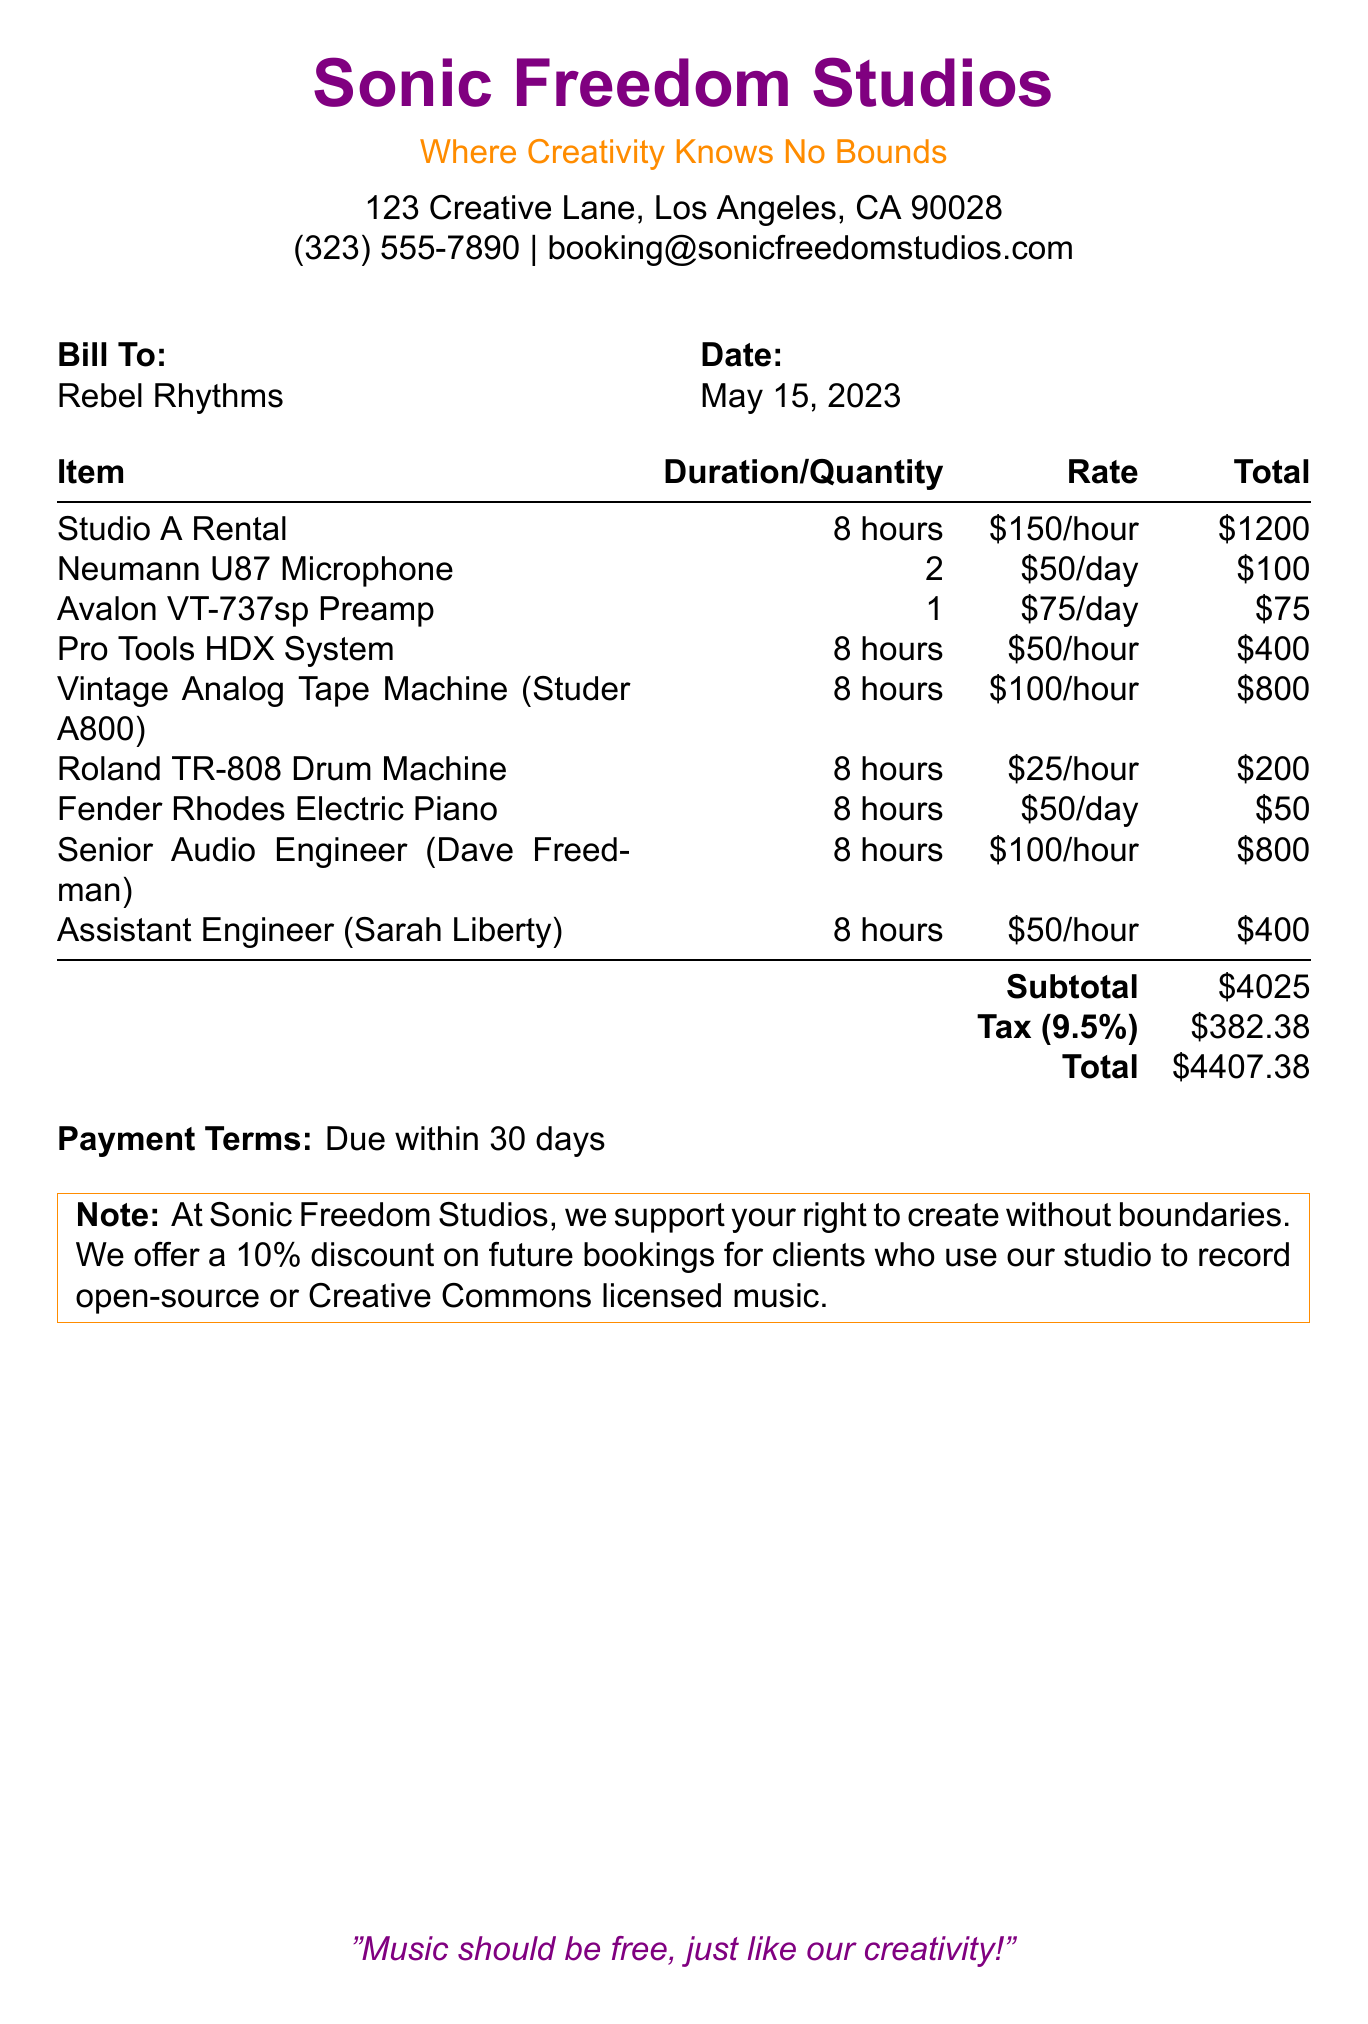What is the name of the studio? The name of the studio is listed at the top of the document.
Answer: Sonic Freedom Studios What is the subtotal amount? The subtotal amount is found in the section detailing costs of items and services.
Answer: $4025 Who is the assistant engineer? The assistant engineer is mentioned in the list of personnel providing services during the session.
Answer: Sarah Liberty What was the rental duration for Studio A? The rental duration for Studio A is specified in the itemized list of services.
Answer: 8 hours How much is the charge for the Neumann U87 Microphone? The total charge for the Neumann U87 Microphone is found in the detailed charges.
Answer: $100 What is the total amount due? The total amount due is calculated at the bottom of the document.
Answer: $4407.38 What is the tax rate applied? The tax rate is specified near the subtotal and total sections of the document.
Answer: 9.5% What is the payment term? The payment term is outlined in the payment terms section of the document.
Answer: Due within 30 days How much is the discount for future bookings? The discount on future bookings is mentioned in the notes at the end of the document.
Answer: 10% 